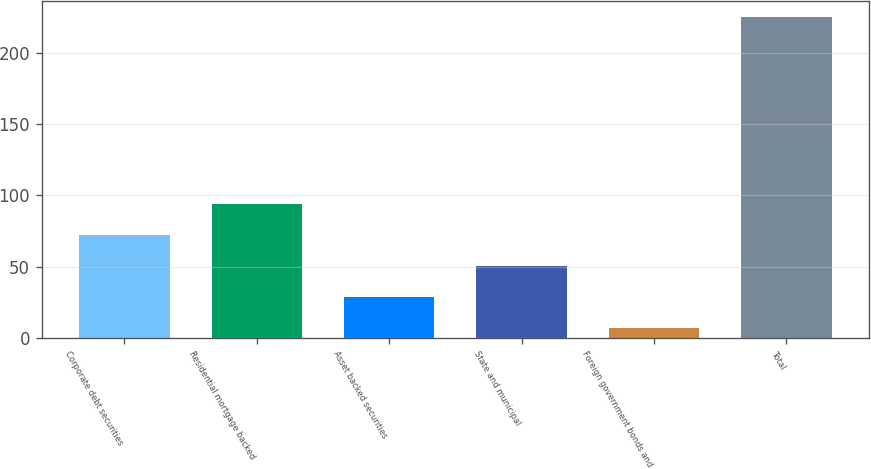Convert chart. <chart><loc_0><loc_0><loc_500><loc_500><bar_chart><fcel>Corporate debt securities<fcel>Residential mortgage backed<fcel>Asset backed securities<fcel>State and municipal<fcel>Foreign government bonds and<fcel>Total<nl><fcel>72.4<fcel>94.2<fcel>28.8<fcel>50.6<fcel>7<fcel>225<nl></chart> 